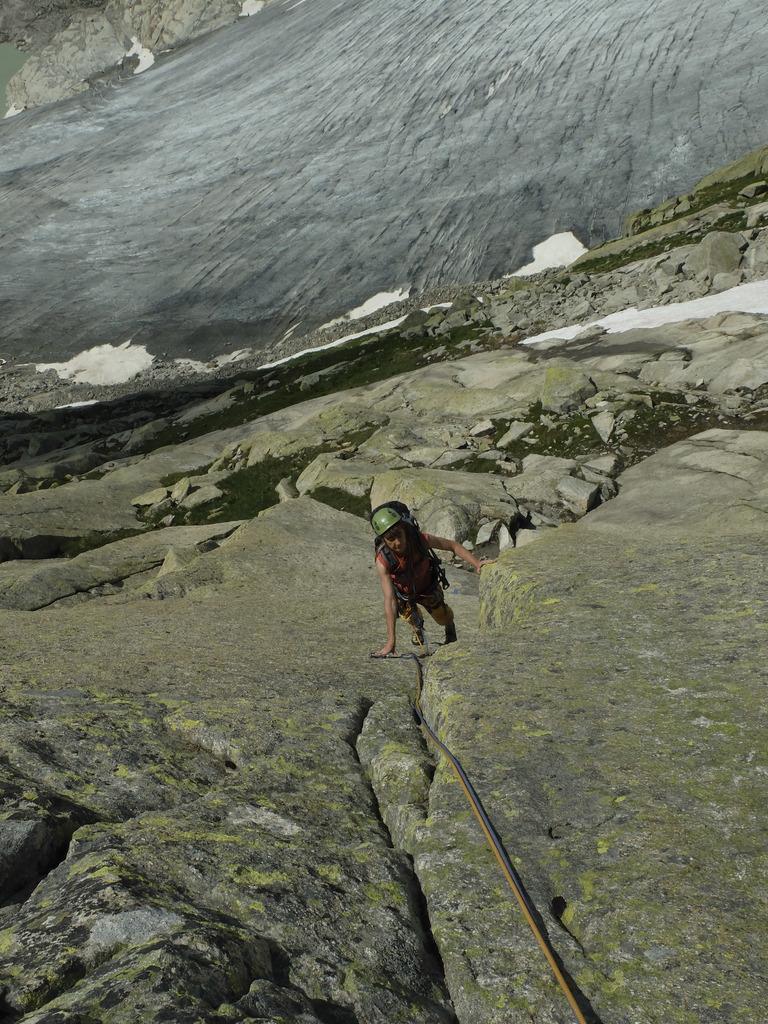Please provide a concise description of this image. In this image in the center there is one man who is standing, and at the bottom there are some mountains. In the background there are some mountains and a river. 